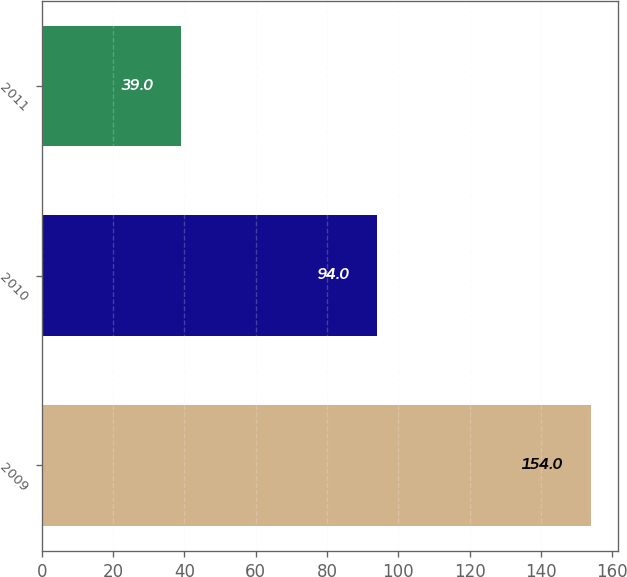Convert chart to OTSL. <chart><loc_0><loc_0><loc_500><loc_500><bar_chart><fcel>2009<fcel>2010<fcel>2011<nl><fcel>154<fcel>94<fcel>39<nl></chart> 